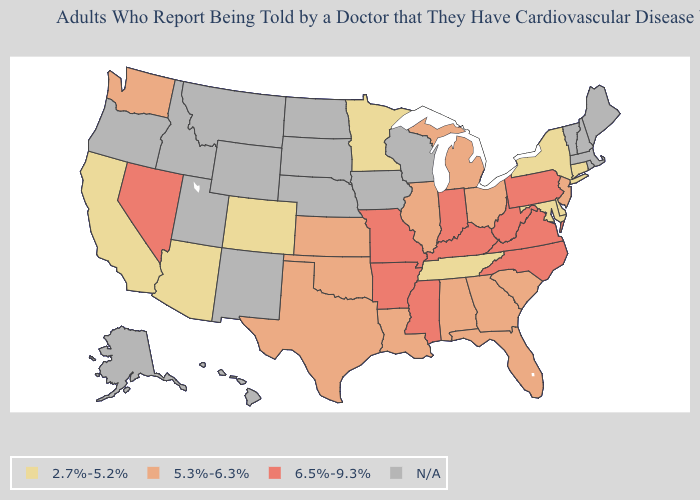What is the highest value in the USA?
Give a very brief answer. 6.5%-9.3%. What is the lowest value in the Northeast?
Quick response, please. 2.7%-5.2%. Among the states that border New Jersey , does Pennsylvania have the highest value?
Give a very brief answer. Yes. Name the states that have a value in the range 2.7%-5.2%?
Concise answer only. Arizona, California, Colorado, Connecticut, Delaware, Maryland, Minnesota, New York, Tennessee. Is the legend a continuous bar?
Write a very short answer. No. How many symbols are there in the legend?
Short answer required. 4. What is the value of California?
Be succinct. 2.7%-5.2%. Which states hav the highest value in the MidWest?
Be succinct. Indiana, Missouri. Does Michigan have the highest value in the USA?
Write a very short answer. No. What is the lowest value in states that border Missouri?
Write a very short answer. 2.7%-5.2%. What is the highest value in states that border Wisconsin?
Short answer required. 5.3%-6.3%. Which states hav the highest value in the MidWest?
Concise answer only. Indiana, Missouri. Name the states that have a value in the range 6.5%-9.3%?
Short answer required. Arkansas, Indiana, Kentucky, Mississippi, Missouri, Nevada, North Carolina, Pennsylvania, Virginia, West Virginia. 